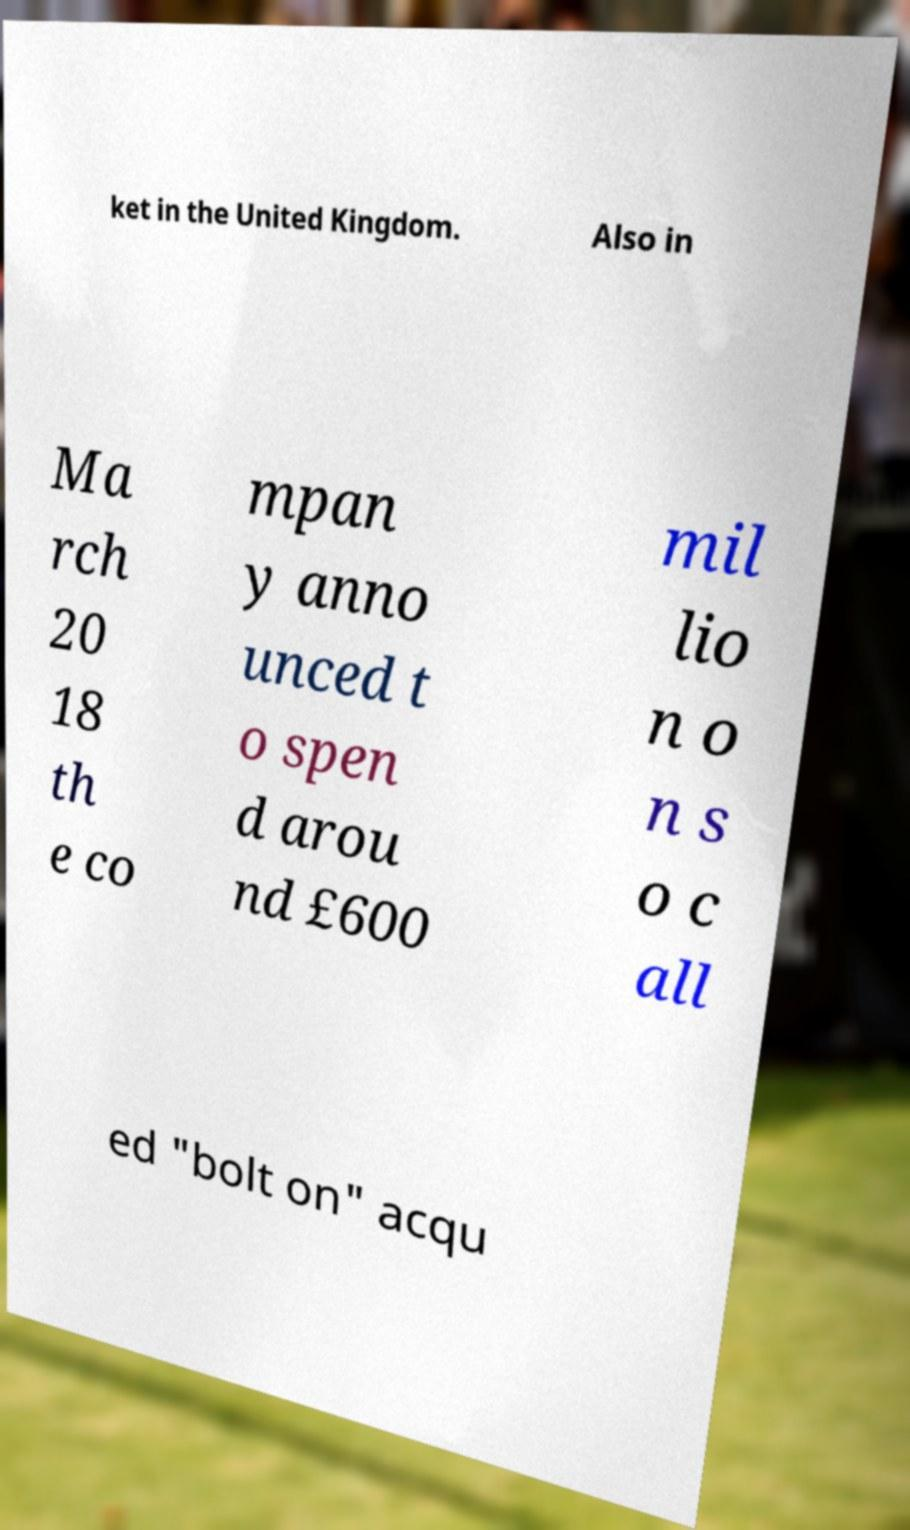Can you accurately transcribe the text from the provided image for me? ket in the United Kingdom. Also in Ma rch 20 18 th e co mpan y anno unced t o spen d arou nd £600 mil lio n o n s o c all ed "bolt on" acqu 